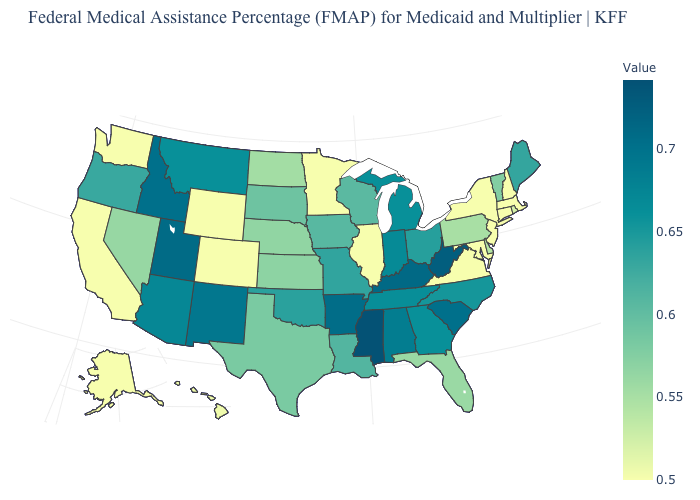Does Alaska have a higher value than Montana?
Be succinct. No. Among the states that border Maryland , which have the highest value?
Be succinct. West Virginia. Does Ohio have the highest value in the USA?
Be succinct. No. Does Michigan have a higher value than Missouri?
Write a very short answer. Yes. Does the map have missing data?
Give a very brief answer. No. 